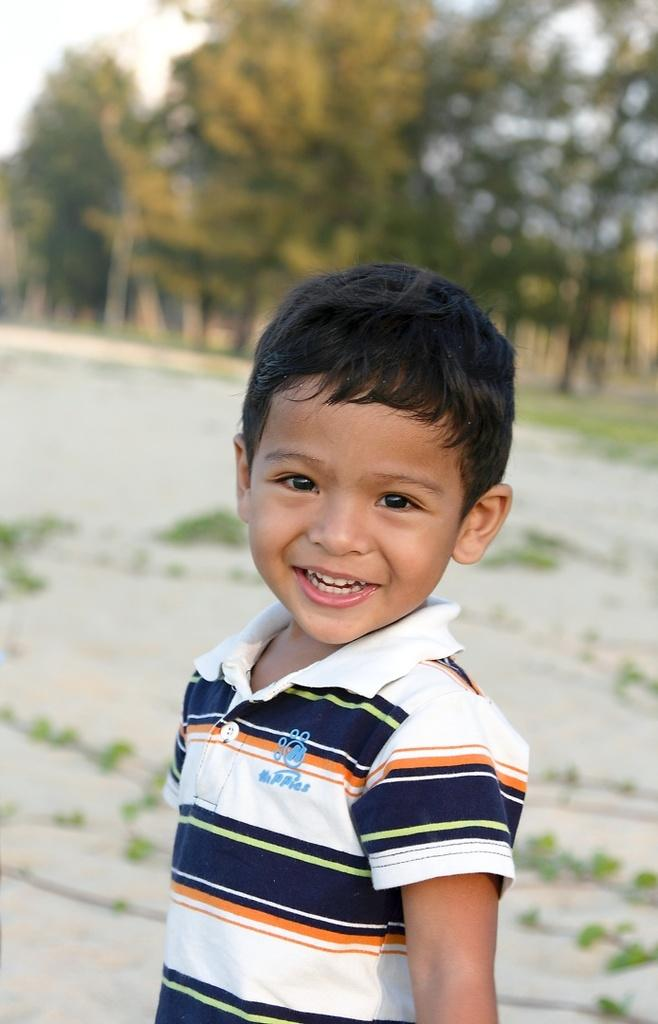What is the main subject of the image? The main subject of the image is a kid. What can be seen in the background of the image? There are trees in the background of the image. Can you tell me how many snakes are slithering around the kid in the image? There are no snakes present in the image; it features a kid with trees in the background. What type of paste is being exchanged between the kid and the trees in the image? There is no paste or exchange happening between the kid and the trees in the image. 